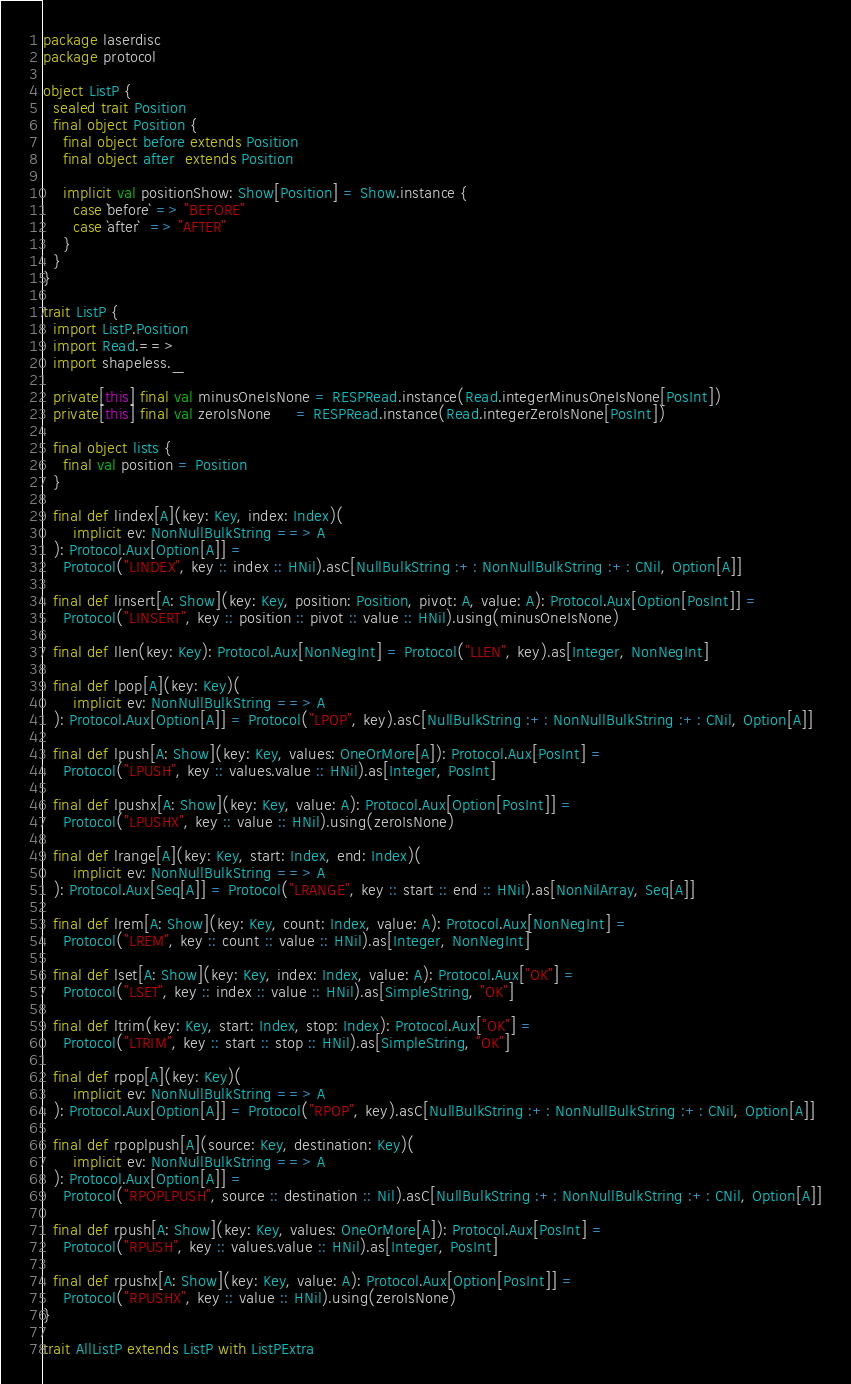<code> <loc_0><loc_0><loc_500><loc_500><_Scala_>package laserdisc
package protocol

object ListP {
  sealed trait Position
  final object Position {
    final object before extends Position
    final object after  extends Position

    implicit val positionShow: Show[Position] = Show.instance {
      case `before` => "BEFORE"
      case `after`  => "AFTER"
    }
  }
}

trait ListP {
  import ListP.Position
  import Read.==>
  import shapeless._

  private[this] final val minusOneIsNone = RESPRead.instance(Read.integerMinusOneIsNone[PosInt])
  private[this] final val zeroIsNone     = RESPRead.instance(Read.integerZeroIsNone[PosInt])

  final object lists {
    final val position = Position
  }

  final def lindex[A](key: Key, index: Index)(
      implicit ev: NonNullBulkString ==> A
  ): Protocol.Aux[Option[A]] =
    Protocol("LINDEX", key :: index :: HNil).asC[NullBulkString :+: NonNullBulkString :+: CNil, Option[A]]

  final def linsert[A: Show](key: Key, position: Position, pivot: A, value: A): Protocol.Aux[Option[PosInt]] =
    Protocol("LINSERT", key :: position :: pivot :: value :: HNil).using(minusOneIsNone)

  final def llen(key: Key): Protocol.Aux[NonNegInt] = Protocol("LLEN", key).as[Integer, NonNegInt]

  final def lpop[A](key: Key)(
      implicit ev: NonNullBulkString ==> A
  ): Protocol.Aux[Option[A]] = Protocol("LPOP", key).asC[NullBulkString :+: NonNullBulkString :+: CNil, Option[A]]

  final def lpush[A: Show](key: Key, values: OneOrMore[A]): Protocol.Aux[PosInt] =
    Protocol("LPUSH", key :: values.value :: HNil).as[Integer, PosInt]

  final def lpushx[A: Show](key: Key, value: A): Protocol.Aux[Option[PosInt]] =
    Protocol("LPUSHX", key :: value :: HNil).using(zeroIsNone)

  final def lrange[A](key: Key, start: Index, end: Index)(
      implicit ev: NonNullBulkString ==> A
  ): Protocol.Aux[Seq[A]] = Protocol("LRANGE", key :: start :: end :: HNil).as[NonNilArray, Seq[A]]

  final def lrem[A: Show](key: Key, count: Index, value: A): Protocol.Aux[NonNegInt] =
    Protocol("LREM", key :: count :: value :: HNil).as[Integer, NonNegInt]

  final def lset[A: Show](key: Key, index: Index, value: A): Protocol.Aux["OK"] =
    Protocol("LSET", key :: index :: value :: HNil).as[SimpleString, "OK"]

  final def ltrim(key: Key, start: Index, stop: Index): Protocol.Aux["OK"] =
    Protocol("LTRIM", key :: start :: stop :: HNil).as[SimpleString, "OK"]

  final def rpop[A](key: Key)(
      implicit ev: NonNullBulkString ==> A
  ): Protocol.Aux[Option[A]] = Protocol("RPOP", key).asC[NullBulkString :+: NonNullBulkString :+: CNil, Option[A]]

  final def rpoplpush[A](source: Key, destination: Key)(
      implicit ev: NonNullBulkString ==> A
  ): Protocol.Aux[Option[A]] =
    Protocol("RPOPLPUSH", source :: destination :: Nil).asC[NullBulkString :+: NonNullBulkString :+: CNil, Option[A]]

  final def rpush[A: Show](key: Key, values: OneOrMore[A]): Protocol.Aux[PosInt] =
    Protocol("RPUSH", key :: values.value :: HNil).as[Integer, PosInt]

  final def rpushx[A: Show](key: Key, value: A): Protocol.Aux[Option[PosInt]] =
    Protocol("RPUSHX", key :: value :: HNil).using(zeroIsNone)
}

trait AllListP extends ListP with ListPExtra
</code> 